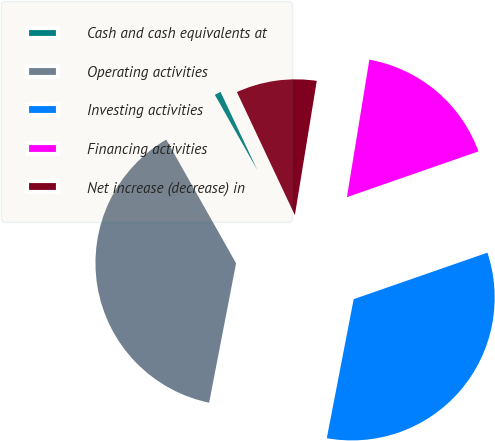<chart> <loc_0><loc_0><loc_500><loc_500><pie_chart><fcel>Cash and cash equivalents at<fcel>Operating activities<fcel>Investing activities<fcel>Financing activities<fcel>Net increase (decrease) in<nl><fcel>1.18%<fcel>38.78%<fcel>33.37%<fcel>17.1%<fcel>9.58%<nl></chart> 